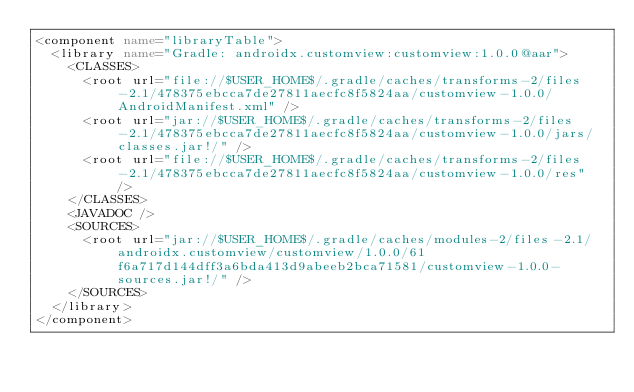<code> <loc_0><loc_0><loc_500><loc_500><_XML_><component name="libraryTable">
  <library name="Gradle: androidx.customview:customview:1.0.0@aar">
    <CLASSES>
      <root url="file://$USER_HOME$/.gradle/caches/transforms-2/files-2.1/478375ebcca7de27811aecfc8f5824aa/customview-1.0.0/AndroidManifest.xml" />
      <root url="jar://$USER_HOME$/.gradle/caches/transforms-2/files-2.1/478375ebcca7de27811aecfc8f5824aa/customview-1.0.0/jars/classes.jar!/" />
      <root url="file://$USER_HOME$/.gradle/caches/transforms-2/files-2.1/478375ebcca7de27811aecfc8f5824aa/customview-1.0.0/res" />
    </CLASSES>
    <JAVADOC />
    <SOURCES>
      <root url="jar://$USER_HOME$/.gradle/caches/modules-2/files-2.1/androidx.customview/customview/1.0.0/61f6a717d144dff3a6bda413d9abeeb2bca71581/customview-1.0.0-sources.jar!/" />
    </SOURCES>
  </library>
</component></code> 